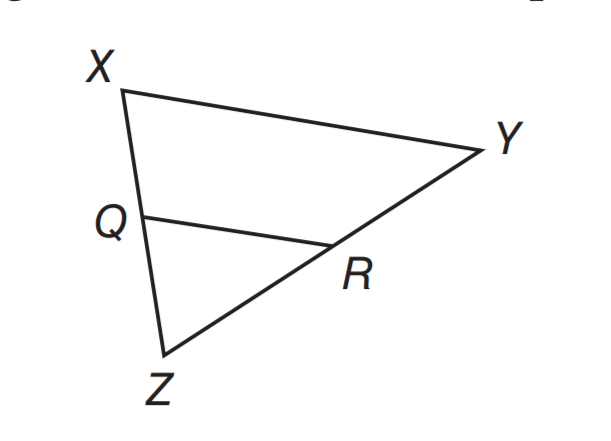Question: If Q R \parallel X Y, X Q = 15, Q Z = 12, and Y R = 20, what is the length of R Z.
Choices:
A. 15
B. 16
C. 18
D. 24
Answer with the letter. Answer: B Question: If Q R \parallel X Y, X Q \cong Q Z, and Q R = 9.5 units, what is the length of X Y.
Choices:
A. 4.75
B. 9.5
C. 19
D. 28.5
Answer with the letter. Answer: C 